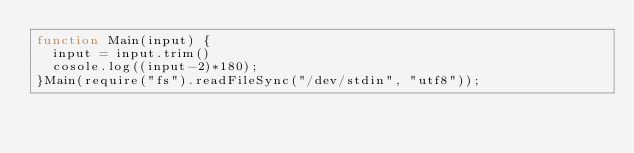Convert code to text. <code><loc_0><loc_0><loc_500><loc_500><_JavaScript_>function Main(input) {
  input = input.trim()
  cosole.log((input-2)*180);
}Main(require("fs").readFileSync("/dev/stdin", "utf8"));
</code> 